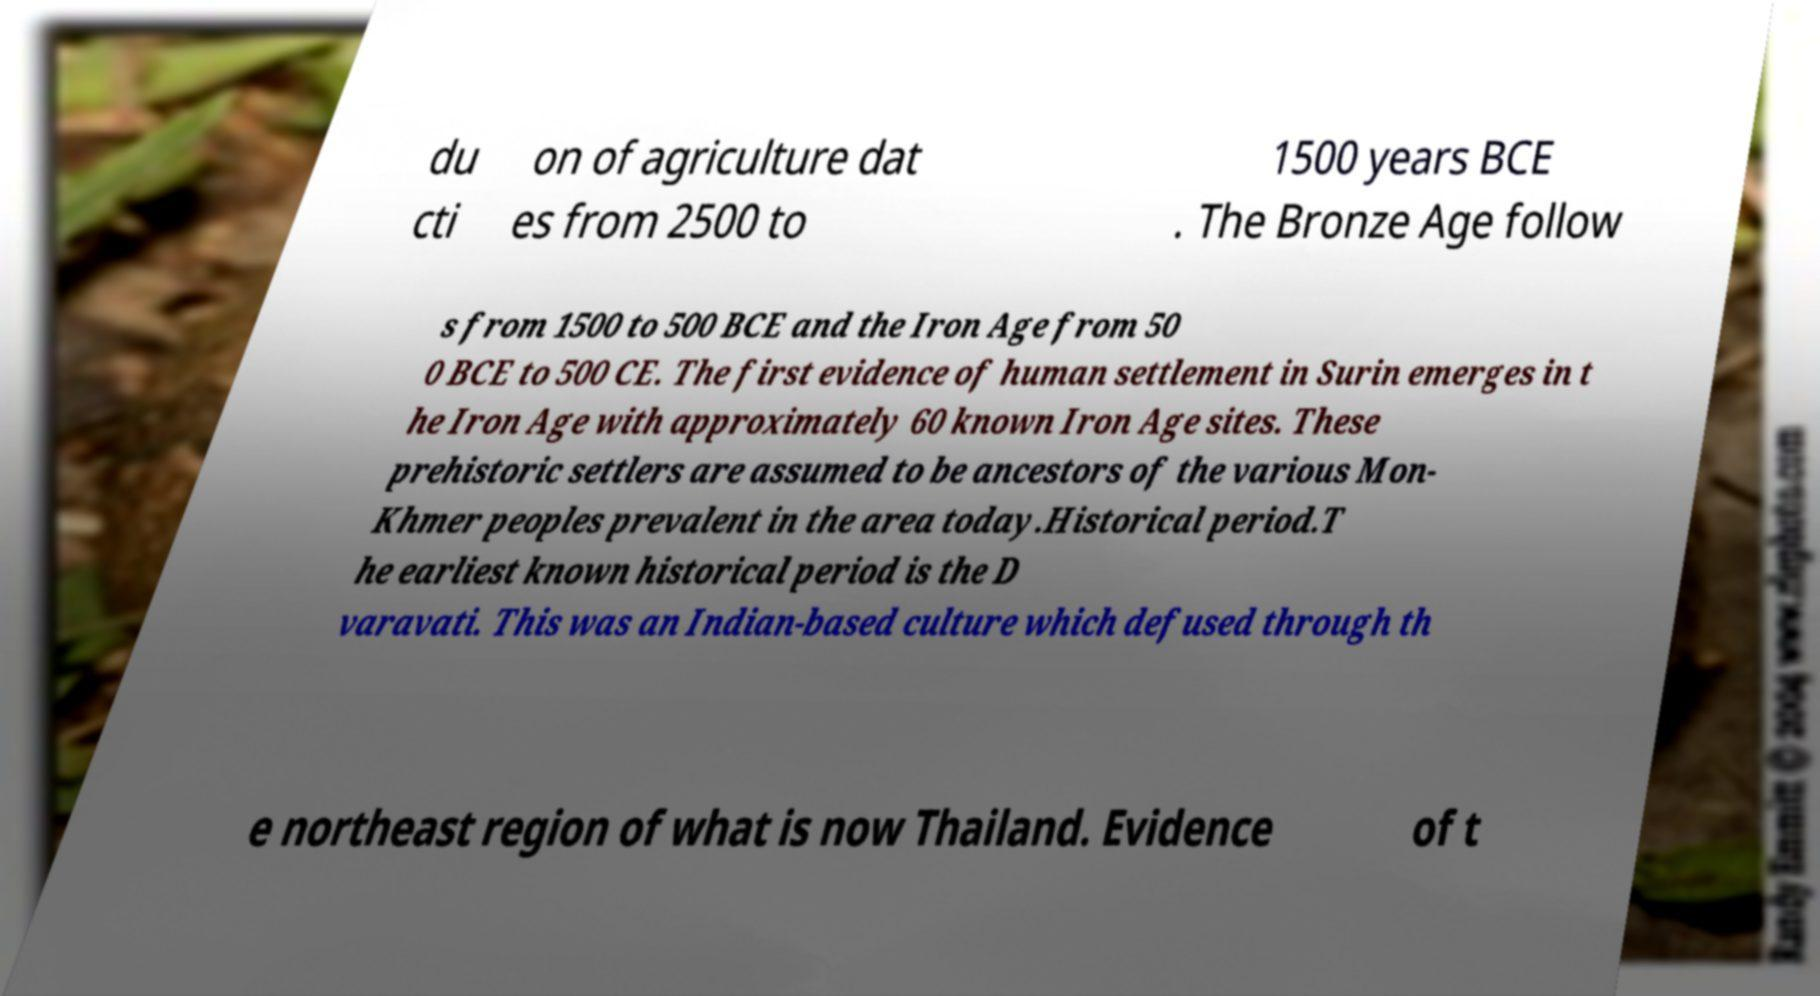Please read and relay the text visible in this image. What does it say? du cti on of agriculture dat es from 2500 to 1500 years BCE . The Bronze Age follow s from 1500 to 500 BCE and the Iron Age from 50 0 BCE to 500 CE. The first evidence of human settlement in Surin emerges in t he Iron Age with approximately 60 known Iron Age sites. These prehistoric settlers are assumed to be ancestors of the various Mon- Khmer peoples prevalent in the area today.Historical period.T he earliest known historical period is the D varavati. This was an Indian-based culture which defused through th e northeast region of what is now Thailand. Evidence of t 